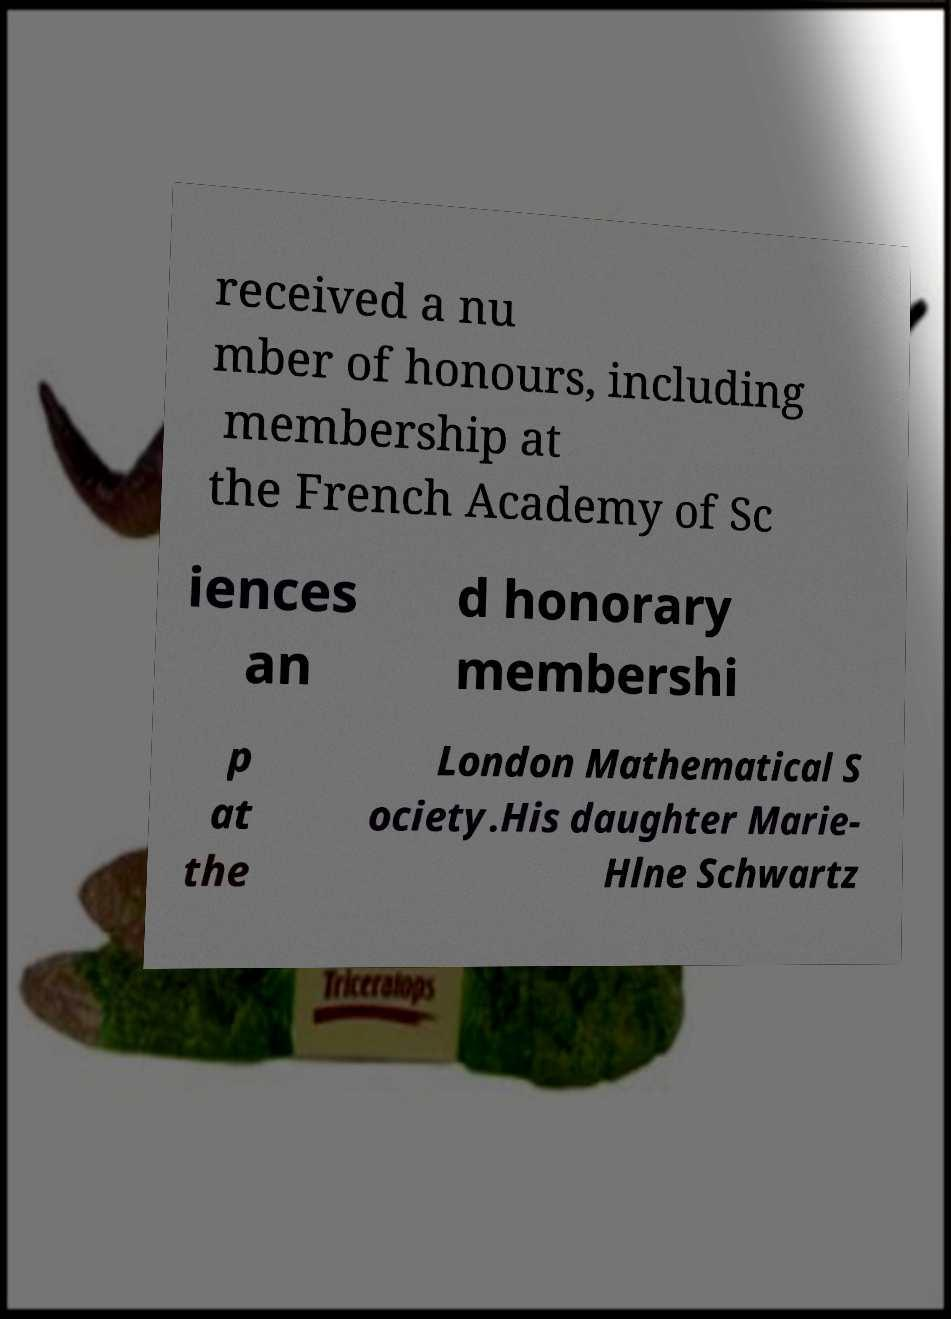Please read and relay the text visible in this image. What does it say? received a nu mber of honours, including membership at the French Academy of Sc iences an d honorary membershi p at the London Mathematical S ociety.His daughter Marie- Hlne Schwartz 